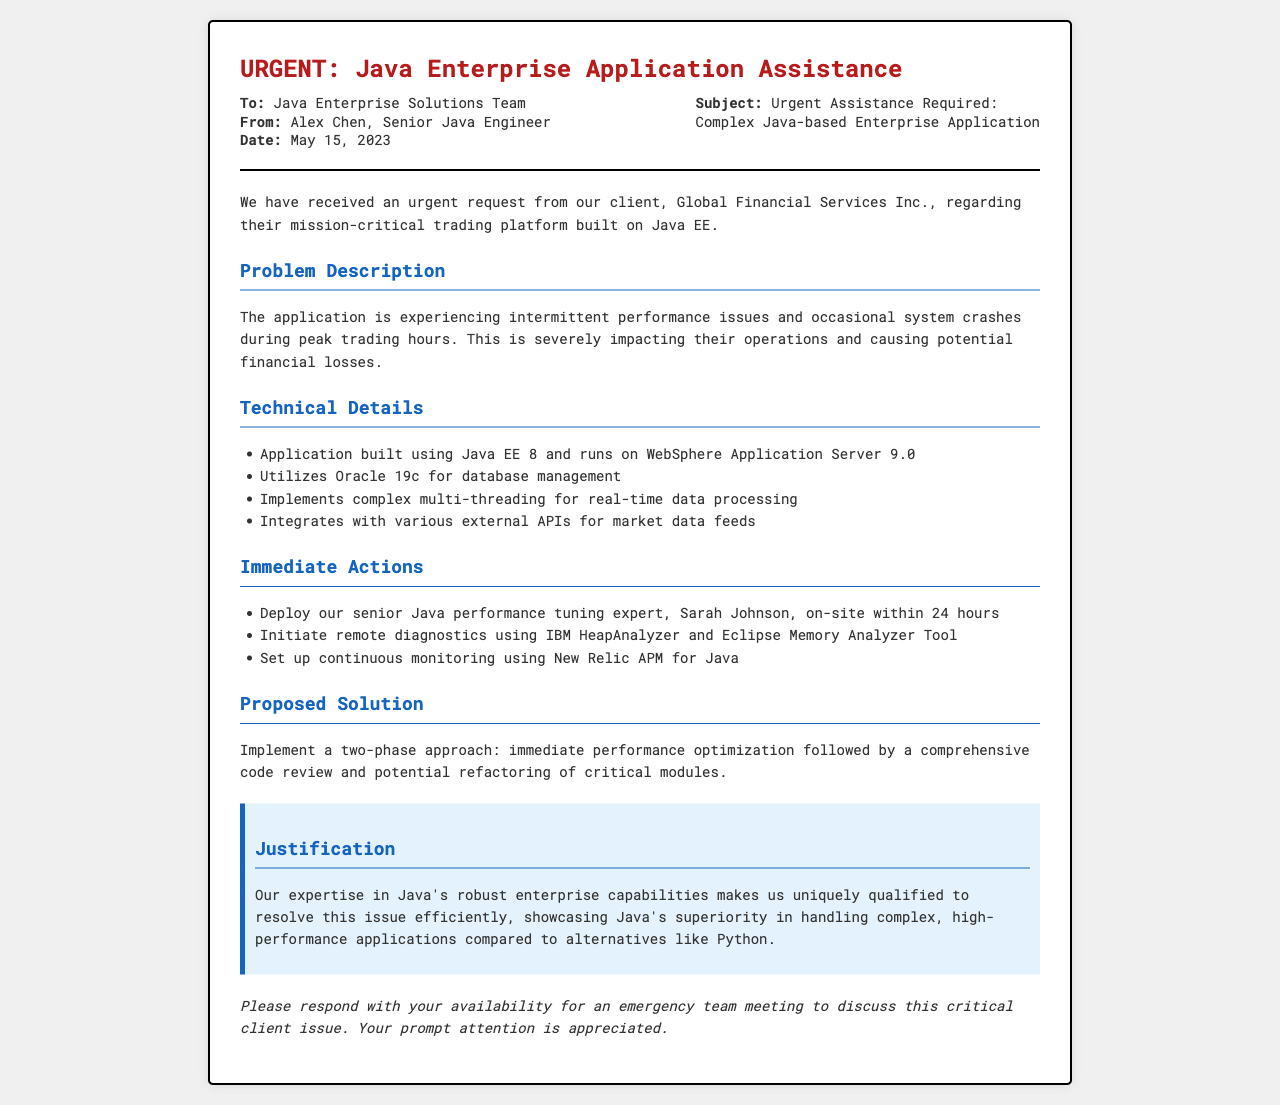What is the client's name? The client's name is mentioned in the document as Global Financial Services Inc.
Answer: Global Financial Services Inc When was the fax sent? The date on the fax is specified to be May 15, 2023.
Answer: May 15, 2023 What is the main issue with the application? The document states that the main issue is intermittent performance issues and occasional system crashes.
Answer: Performance issues and crashes Who is the senior Java performance tuning expert? The document identifies the senior Java performance tuning expert as Sarah Johnson.
Answer: Sarah Johnson What is the database management system used? The database management system mentioned in the document is Oracle 19c.
Answer: Oracle 19c What tools will be used for remote diagnostics? The remote diagnostics will utilize IBM HeapAnalyzer and Eclipse Memory Analyzer Tool.
Answer: IBM HeapAnalyzer and Eclipse Memory Analyzer Tool What is the proposed two-phase approach? The approach includes immediate performance optimization followed by a comprehensive code review and potential refactoring.
Answer: Performance optimization and code review Why is the team uniquely qualified to resolve the issue? The justification states their expertise in Java's robust enterprise capabilities makes them uniquely qualified.
Answer: Java's robust enterprise capabilities 